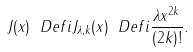<formula> <loc_0><loc_0><loc_500><loc_500>J ( x ) \ D e f i J _ { \lambda , k } ( x ) \ D e f i \frac { \lambda x ^ { 2 k } } { ( 2 k ) ! } .</formula> 